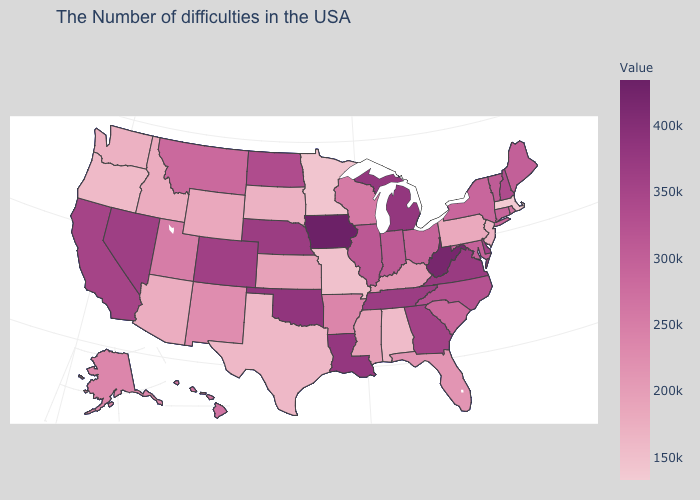Among the states that border Montana , which have the highest value?
Write a very short answer. North Dakota. Among the states that border Maine , which have the lowest value?
Quick response, please. New Hampshire. Among the states that border Utah , which have the lowest value?
Quick response, please. Arizona. 